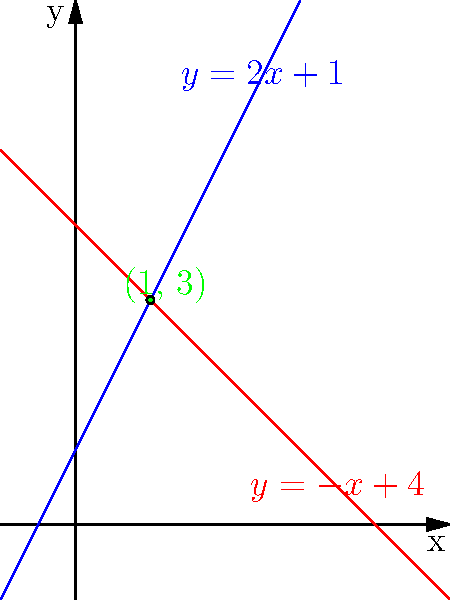Given two lines in a 2D coordinate system, $y = 2x + 1$ and $y = -x + 4$, determine their intersection point using a systematic algebraic approach. How would you implement this solution in a computer program without relying on neural network techniques? To find the intersection point of two lines, we need to solve the system of equations:

$$\begin{cases}
y = 2x + 1 \\
y = -x + 4
\end{cases}$$

Step 1: Set the equations equal to each other since they represent the same point (x, y) at intersection.
$2x + 1 = -x + 4$

Step 2: Solve for x by isolating it on one side of the equation.
$2x + x = 4 - 1$
$3x = 3$
$x = 1$

Step 3: Substitute the x-value into either of the original equations to find y.
Using $y = 2x + 1$:
$y = 2(1) + 1 = 3$

Step 4: The intersection point is (1, 3).

Implementation approach:
1. Define a function to represent each line equation.
2. Create a function that takes two line equations as input.
3. Use symbolic manipulation or numerical methods to solve the system of equations.
4. Return the intersection point (x, y).

This solution uses traditional algebraic methods and can be implemented using standard programming techniques without relying on neural networks or other AI-inspired algorithms.
Answer: (1, 3) 